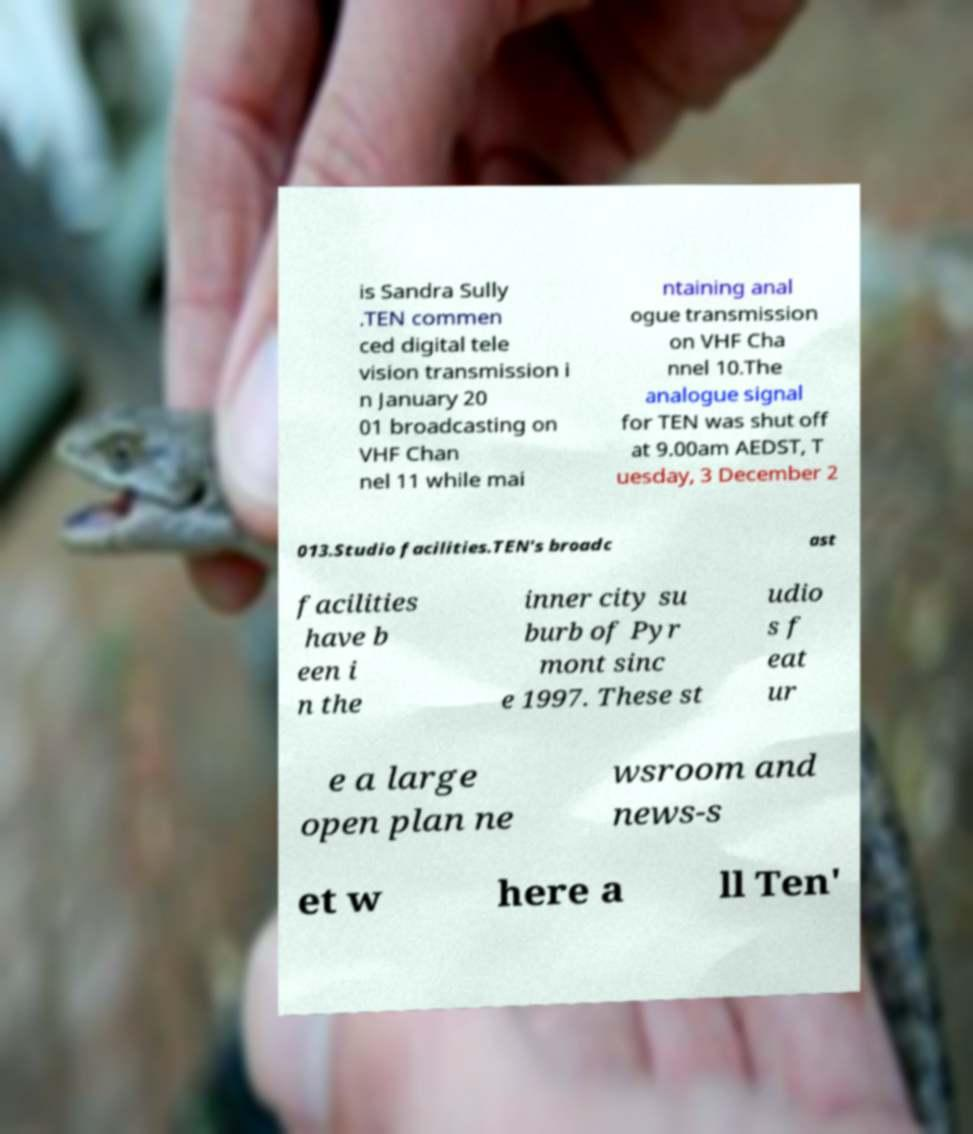Please read and relay the text visible in this image. What does it say? is Sandra Sully .TEN commen ced digital tele vision transmission i n January 20 01 broadcasting on VHF Chan nel 11 while mai ntaining anal ogue transmission on VHF Cha nnel 10.The analogue signal for TEN was shut off at 9.00am AEDST, T uesday, 3 December 2 013.Studio facilities.TEN's broadc ast facilities have b een i n the inner city su burb of Pyr mont sinc e 1997. These st udio s f eat ur e a large open plan ne wsroom and news-s et w here a ll Ten' 